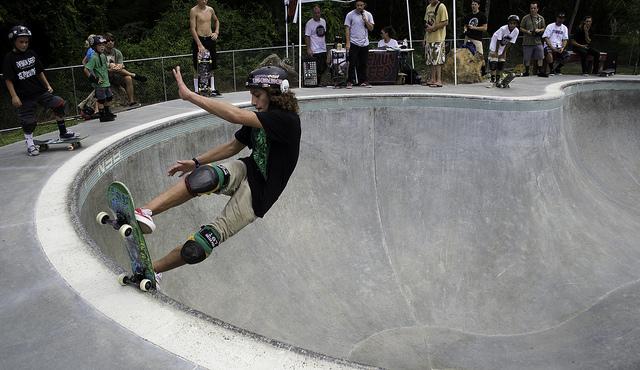What color is the man's board?
Quick response, please. Green. Is the man skateboarding?
Be succinct. Yes. What color is the fence?
Be succinct. Silver. Are both feet on the board?
Give a very brief answer. Yes. 